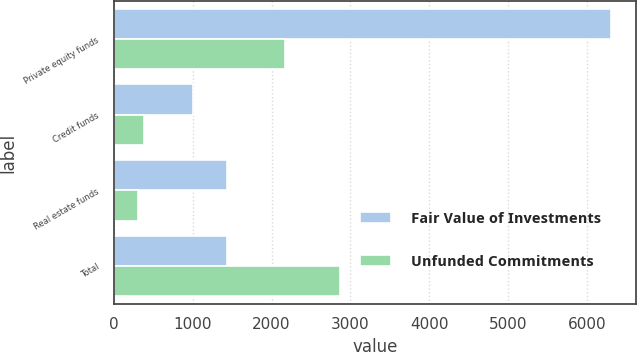Convert chart. <chart><loc_0><loc_0><loc_500><loc_500><stacked_bar_chart><ecel><fcel>Private equity funds<fcel>Credit funds<fcel>Real estate funds<fcel>Total<nl><fcel>Fair Value of Investments<fcel>6307<fcel>1008<fcel>1432<fcel>1432<nl><fcel>Unfunded Commitments<fcel>2175<fcel>383<fcel>310<fcel>2868<nl></chart> 